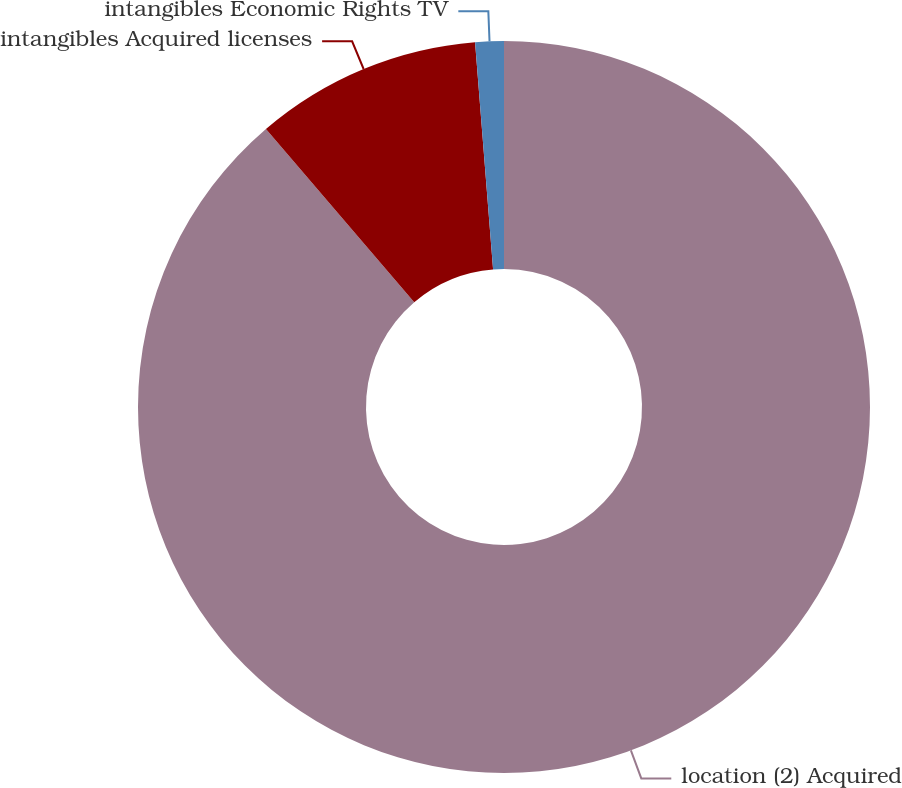Convert chart. <chart><loc_0><loc_0><loc_500><loc_500><pie_chart><fcel>location (2) Acquired<fcel>intangibles Acquired licenses<fcel>intangibles Economic Rights TV<nl><fcel>88.73%<fcel>10.01%<fcel>1.26%<nl></chart> 